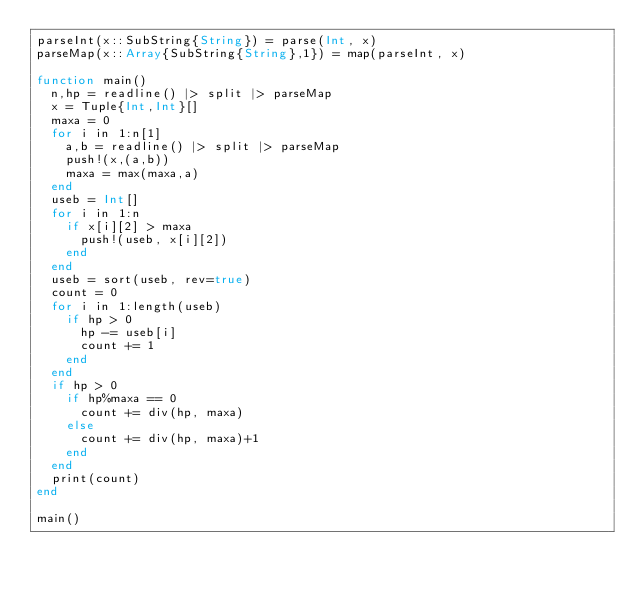<code> <loc_0><loc_0><loc_500><loc_500><_Julia_>parseInt(x::SubString{String}) = parse(Int, x)
parseMap(x::Array{SubString{String},1}) = map(parseInt, x)

function main()
	n,hp = readline() |> split |> parseMap
	x = Tuple{Int,Int}[]
	maxa = 0
	for i in 1:n[1]
		a,b = readline() |> split |> parseMap
		push!(x,(a,b))
		maxa = max(maxa,a)
	end
	useb = Int[]
	for i in 1:n
		if x[i][2] > maxa
			push!(useb, x[i][2])
		end
	end
	useb = sort(useb, rev=true)
	count = 0
	for i in 1:length(useb)
		if hp > 0
			hp -= useb[i]
			count += 1
		end
	end
	if hp > 0
		if hp%maxa == 0
			count += div(hp, maxa)
		else
			count += div(hp, maxa)+1
		end
	end
	print(count)
end

main()</code> 